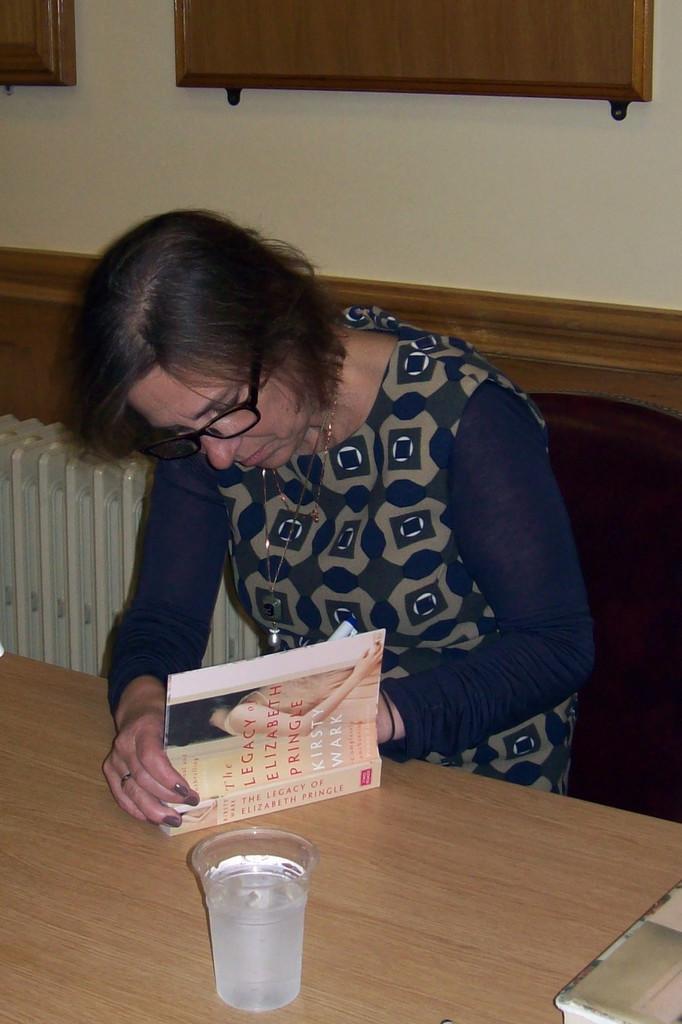In one or two sentences, can you explain what this image depicts? Here we can see a woman sitting on chair writing something in the book present on the table in front of her and there is a glass of water present 